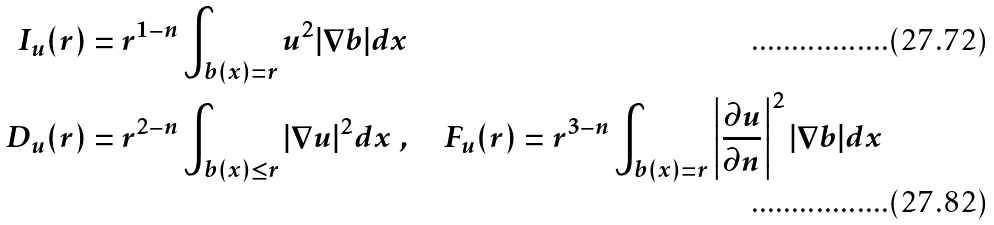<formula> <loc_0><loc_0><loc_500><loc_500>I _ { u } ( r ) & = r ^ { 1 - n } \int _ { b ( x ) = r } u ^ { 2 } | \nabla b | d x \\ D _ { u } ( r ) & = r ^ { 2 - n } \int _ { b ( x ) \leq r } | \nabla u | ^ { 2 } d x \ , \quad F _ { u } ( r ) = r ^ { 3 - n } \int _ { b ( x ) = r } \left | \frac { \partial u } { \partial n } \right | ^ { 2 } | \nabla b | d x</formula> 